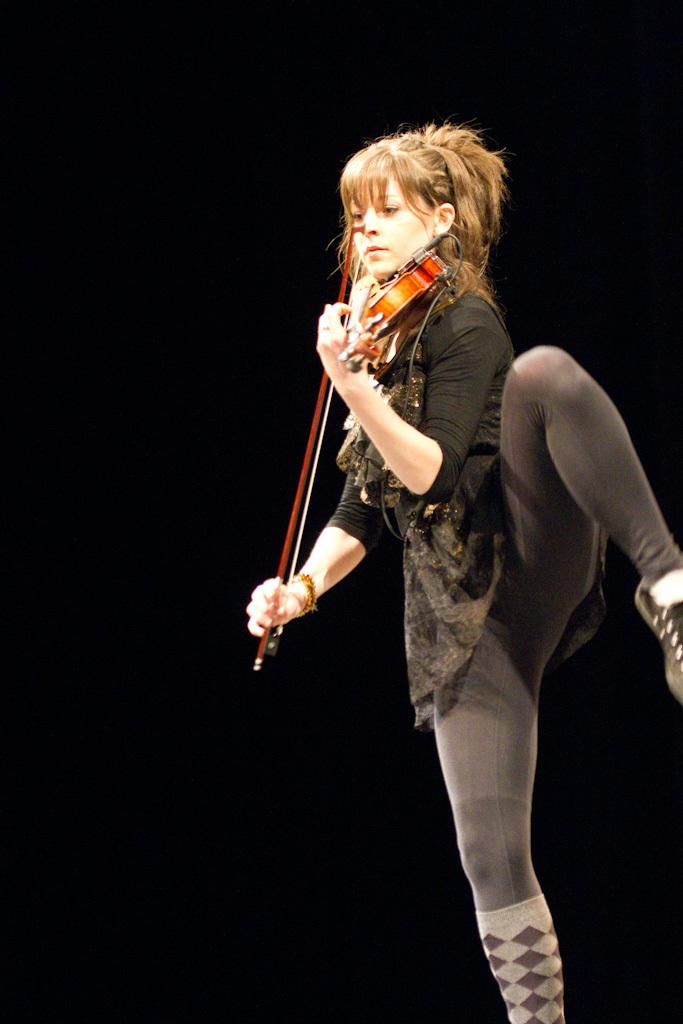Who is the main subject in the image? There is a woman in the image. What is the woman doing in the image? The woman is standing on one leg and playing a violin. What type of bear can be seen pulling a joke in the image? There is no bear or joke present in the image; it features a woman standing on one leg and playing a violin. 